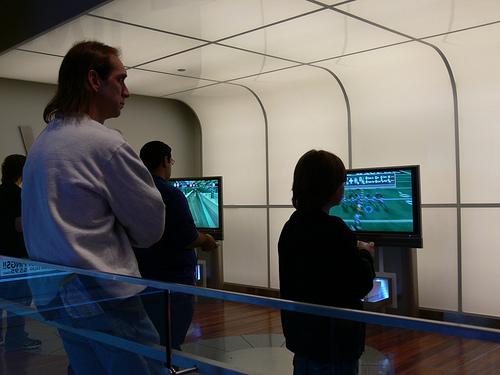Are all these people adults?
Keep it brief. No. How many televisions are in this photo?
Short answer required. 2. What material is the floor made of?
Write a very short answer. Wood. 